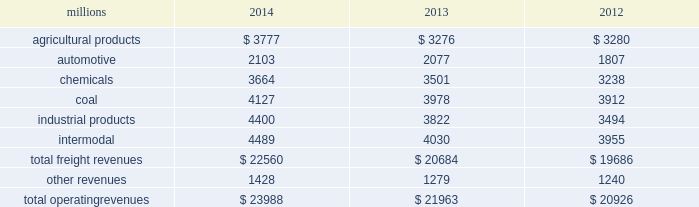Notes to the consolidated financial statements union pacific corporation and subsidiary companies for purposes of this report , unless the context otherwise requires , all references herein to the 201ccorporation 201d , 201ccompany 201d , 201cupc 201d , 201cwe 201d , 201cus 201d , and 201cour 201d mean union pacific corporation and its subsidiaries , including union pacific railroad company , which will be separately referred to herein as 201cuprr 201d or the 201crailroad 201d .
Nature of operations operations and segmentation 2013 we are a class i railroad operating in the u.s .
Our network includes 31974 route miles , linking pacific coast and gulf coast ports with the midwest and eastern u.s .
Gateways and providing several corridors to key mexican gateways .
We own 26012 miles and operate on the remainder pursuant to trackage rights or leases .
We serve the western two-thirds of the country and maintain coordinated schedules with other rail carriers for the handling of freight to and from the atlantic coast , the pacific coast , the southeast , the southwest , canada , and mexico .
Export and import traffic is moved through gulf coast and pacific coast ports and across the mexican and canadian borders .
The railroad , along with its subsidiaries and rail affiliates , is our one reportable operating segment .
Although we provide and review revenue by commodity group , we analyze the net financial results of the railroad as one segment due to the integrated nature of our rail network .
The table provides freight revenue by commodity group : millions 2014 2013 2012 .
Although our revenues are principally derived from customers domiciled in the u.s. , the ultimate points of origination or destination for some products transported by us are outside the u.s .
Each of our commodity groups includes revenue from shipments to and from mexico .
Included in the above table are revenues from our mexico business which amounted to $ 2.3 billion in 2014 , $ 2.1 billion in 2013 , and $ 1.9 billion in 2012 .
Basis of presentation 2013 the consolidated financial statements are presented in accordance with accounting principles generally accepted in the u.s .
( gaap ) as codified in the financial accounting standards board ( fasb ) accounting standards codification ( asc ) .
Significant accounting policies principles of consolidation 2013 the consolidated financial statements include the accounts of union pacific corporation and all of its subsidiaries .
Investments in affiliated companies ( 20% ( 20 % ) to 50% ( 50 % ) owned ) are accounted for using the equity method of accounting .
All intercompany transactions are eliminated .
We currently have no less than majority-owned investments that require consolidation under variable interest entity requirements .
Cash and cash equivalents 2013 cash equivalents consist of investments with original maturities of three months or less .
Accounts receivable 2013 accounts receivable includes receivables reduced by an allowance for doubtful accounts .
The allowance is based upon historical losses , credit worthiness of customers , and current economic conditions .
Receivables not expected to be collected in one year and the associated allowances are classified as other assets in our consolidated statements of financial position. .
What percentage of total freight revenues was the coal commodity group in 2013? 
Computations: (3978 / 21963)
Answer: 0.18112. 